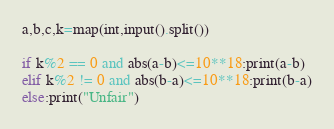Convert code to text. <code><loc_0><loc_0><loc_500><loc_500><_Python_>a,b,c,k=map(int,input().split())

if k%2 == 0 and abs(a-b)<=10**18:print(a-b)
elif k%2 != 0 and abs(b-a)<=10**18:print(b-a)
else:print("Unfair")</code> 